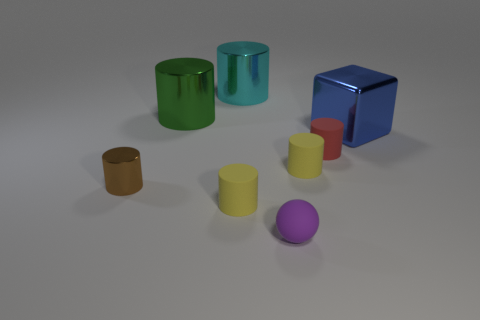Subtract 2 cylinders. How many cylinders are left? 4 Subtract all small red cylinders. How many cylinders are left? 5 Subtract all yellow cylinders. How many cylinders are left? 4 Subtract all yellow cylinders. Subtract all brown spheres. How many cylinders are left? 4 Add 1 gray matte objects. How many objects exist? 9 Subtract all cylinders. How many objects are left? 2 Add 3 large green cylinders. How many large green cylinders exist? 4 Subtract 0 gray balls. How many objects are left? 8 Subtract all brown rubber cylinders. Subtract all big cyan metal objects. How many objects are left? 7 Add 7 large things. How many large things are left? 10 